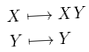Convert formula to latex. <formula><loc_0><loc_0><loc_500><loc_500>X & \longmapsto X Y \\ Y & \longmapsto Y</formula> 